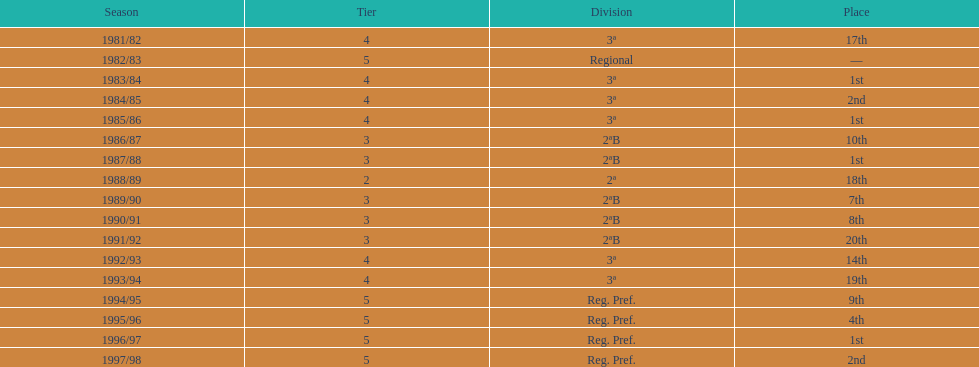In what years did the team participate in a season? 1981/82, 1982/83, 1983/84, 1984/85, 1985/86, 1986/87, 1987/88, 1988/89, 1989/90, 1990/91, 1991/92, 1992/93, 1993/94, 1994/95, 1995/96, 1996/97, 1997/98. Among those years, when did they rank outside the top 10? 1981/82, 1988/89, 1991/92, 1992/93, 1993/94. In which of those years did they experience their poorest performance? 1991/92. 